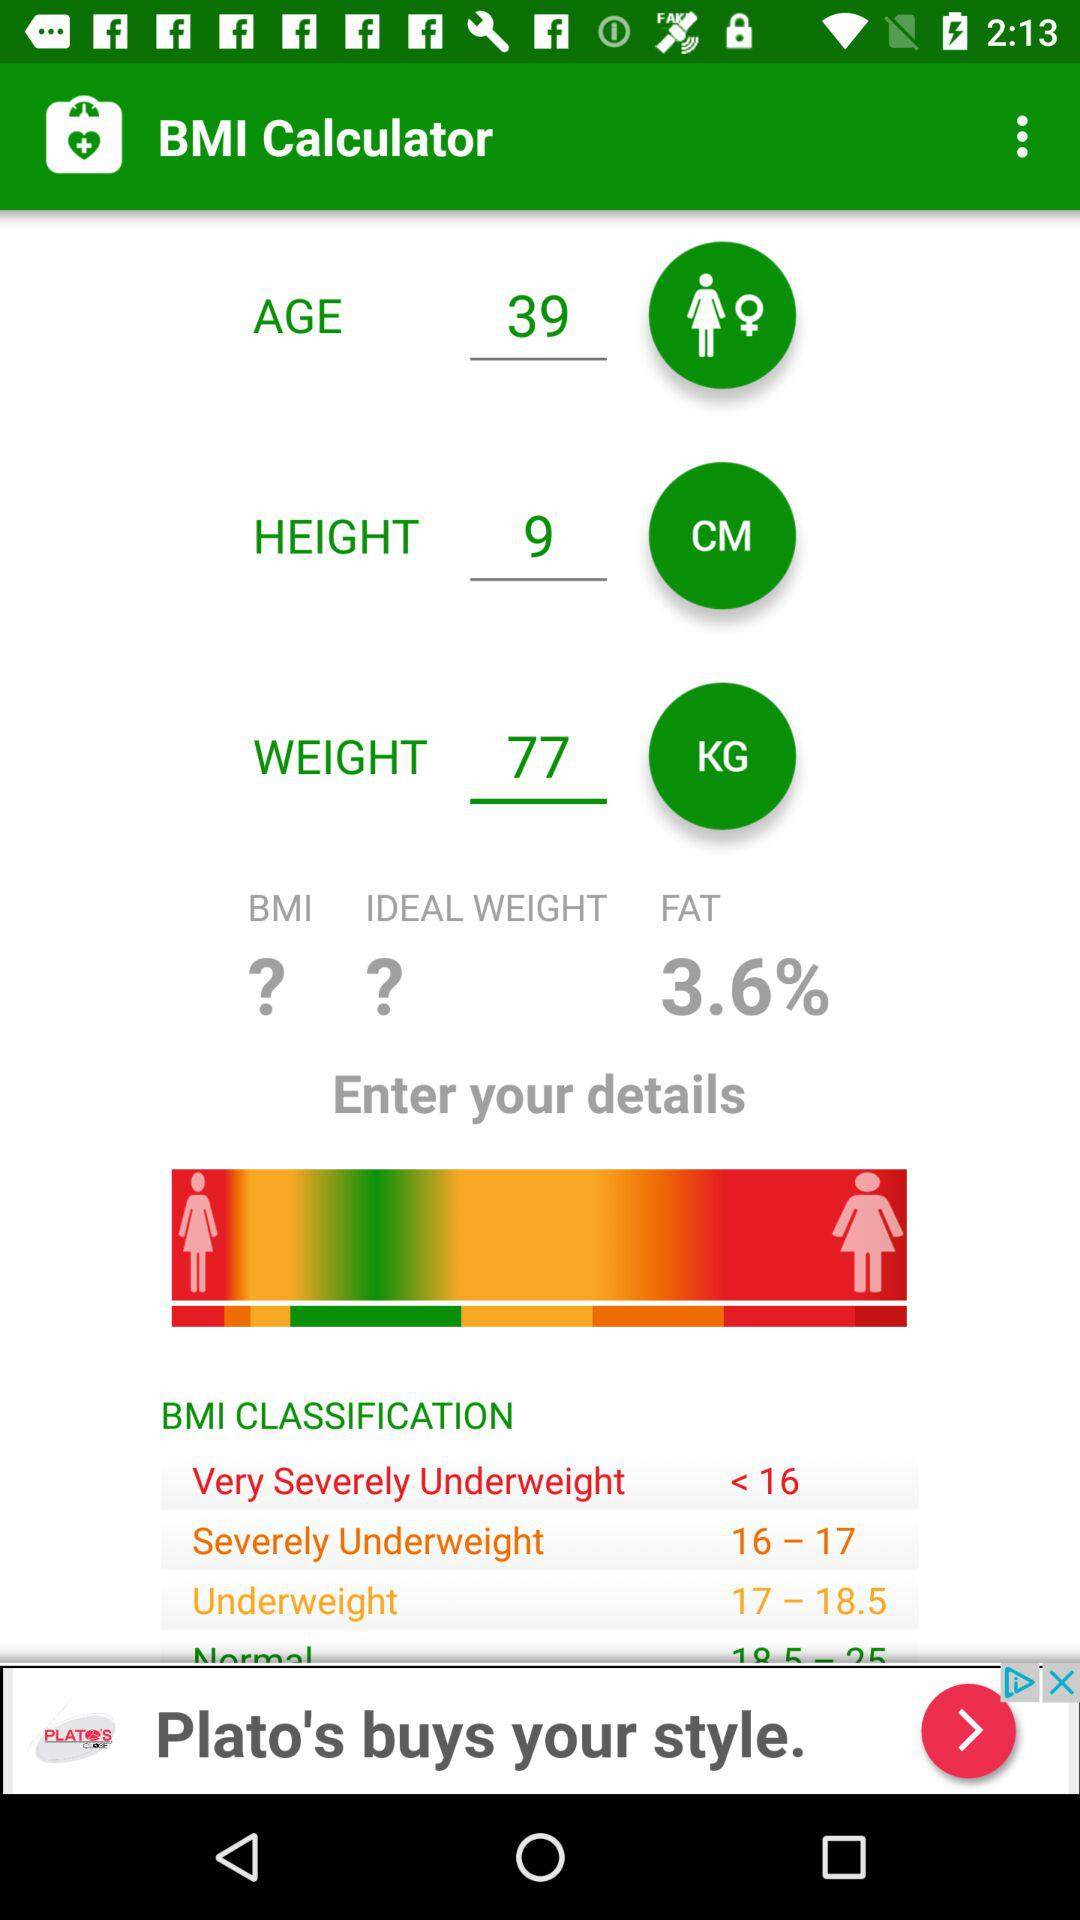What is the range for the "Underweight"? The range is 17 to 18.5. 